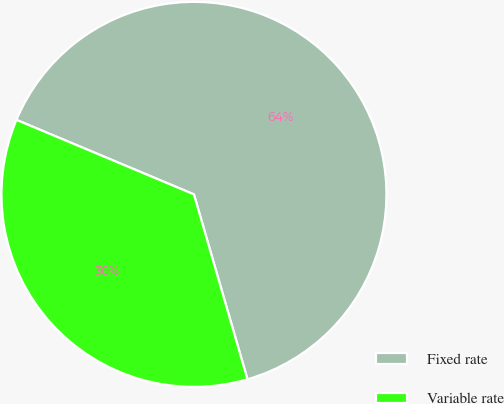Convert chart to OTSL. <chart><loc_0><loc_0><loc_500><loc_500><pie_chart><fcel>Fixed rate<fcel>Variable rate<nl><fcel>64.19%<fcel>35.81%<nl></chart> 